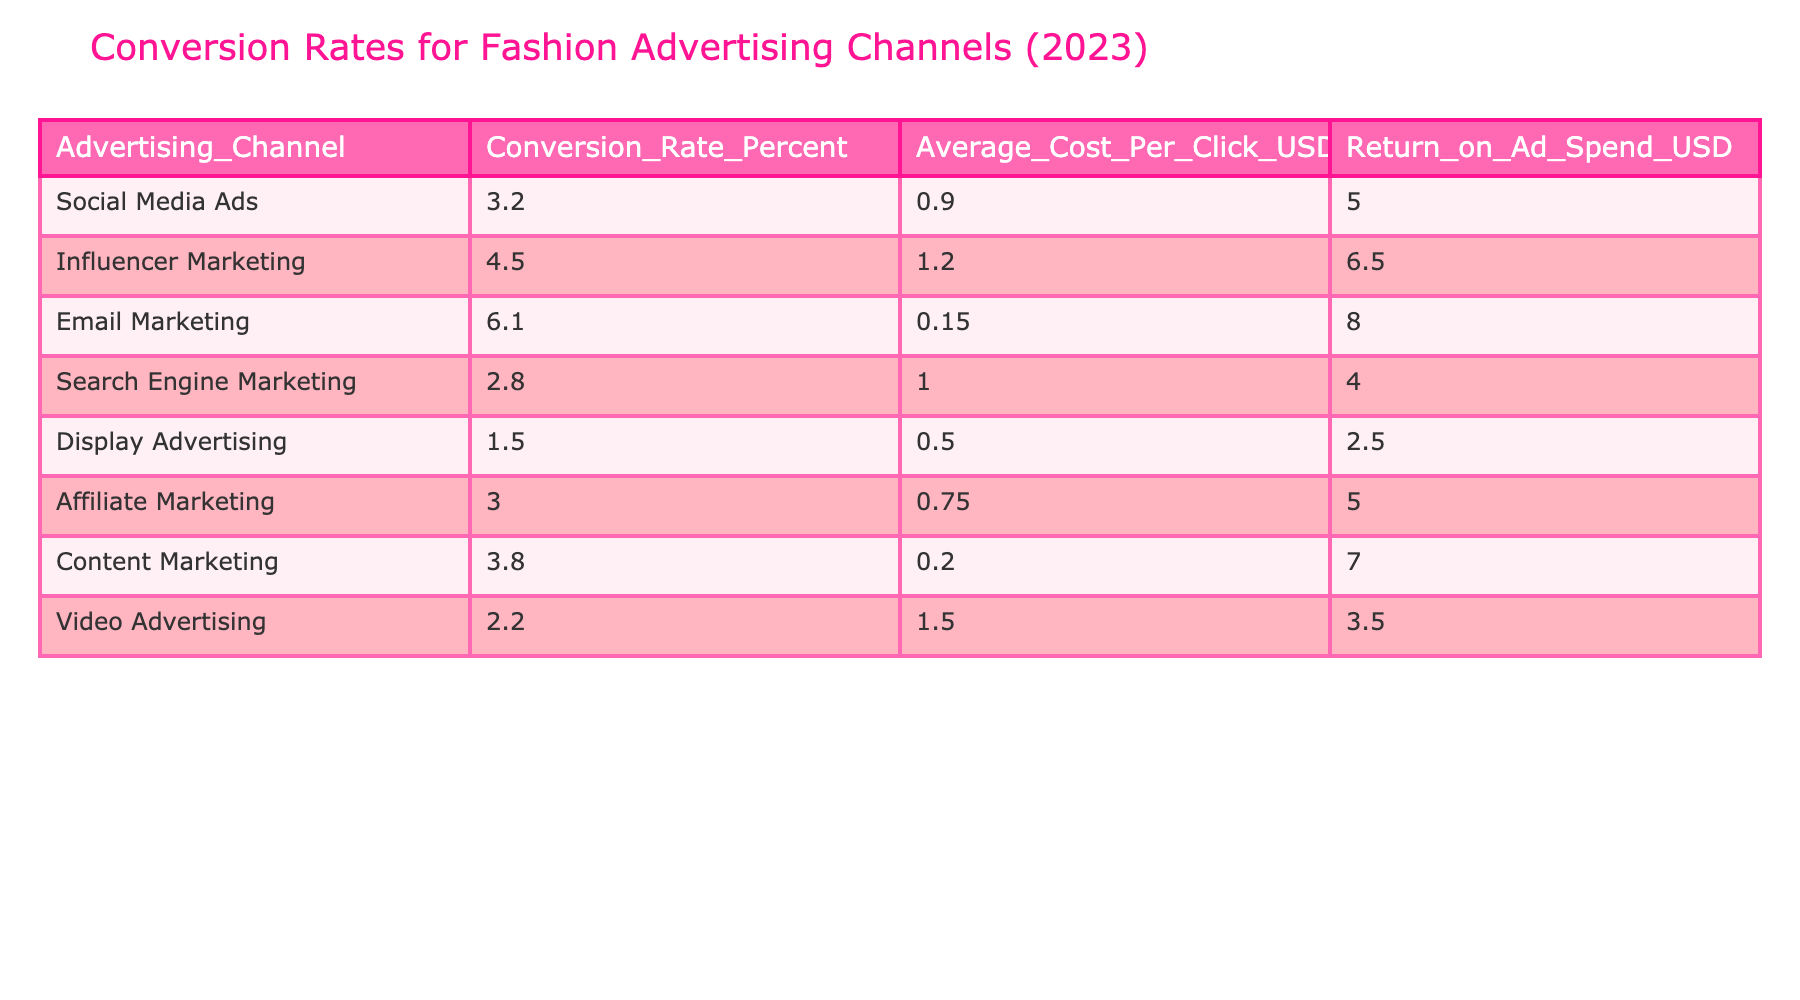What is the conversion rate for Email Marketing? The table shows that the conversion rate for Email Marketing is listed under the column "Conversion_Rate_Percent," where Email Marketing is associated with a conversion rate of 6.1 percent.
Answer: 6.1 percent Which advertising channel has the highest Return on Ad Spend? Looking at the "Return_on_Ad_Spend_USD" column, the values are compared. Influencer Marketing has the highest figure at 6.50 USD.
Answer: Influencer Marketing What is the average conversion rate for the advertising channels listed? To find the average, sum the conversion rates: (3.2 + 4.5 + 6.1 + 2.8 + 1.5 + 3.0 + 3.8 + 2.2) = 27.1. Then divide by the number of channels (8), giving an average of 27.1 / 8 = 3.3875 percent.
Answer: 3.39 percent Is the Average Cost Per Click for Display Advertising less than 1 USD? The table indicates that the Average Cost Per Click for Display Advertising is 0.50 USD. Since 0.50 is less than 1, the statement is true.
Answer: Yes How much higher is the conversion rate for Email Marketing compared to Display Advertising? The conversion rate for Email Marketing is 6.1 percent, while for Display Advertising, it is 1.5 percent. The difference is calculated as 6.1 - 1.5 = 4.6 percent.
Answer: 4.6 percent Which advertising channel has the lowest Return on Ad Spend, and what is the value? By checking the "Return_on_Ad_Spend_USD" column, Display Advertising has the lowest value at 2.50 USD.
Answer: Display Advertising, 2.50 USD How many advertising channels have a conversion rate above 3 percent? By reviewing the "Conversion_Rate_Percent" column, five channels show rates greater than 3 percent: Influencer Marketing (4.5), Email Marketing (6.1), Content Marketing (3.8), Social Media Ads (3.2), and Affiliate Marketing (3.0). Thus, there are five channels.
Answer: 5 channels What is the combined Average Cost Per Click for Social Media Ads and Influencer Marketing? The Average Cost Per Click for Social Media Ads is 0.90 USD, and for Influencer Marketing, it is 1.20 USD. Combining these: 0.90 + 1.20 = 2.10 USD.
Answer: 2.10 USD Did any advertising channels have a conversion rate lower than 2 percent? The table shows that the lowest conversion rate is 1.5 percent for Display Advertising, which is indeed lower than 2 percent. Therefore, the statement is true.
Answer: Yes 